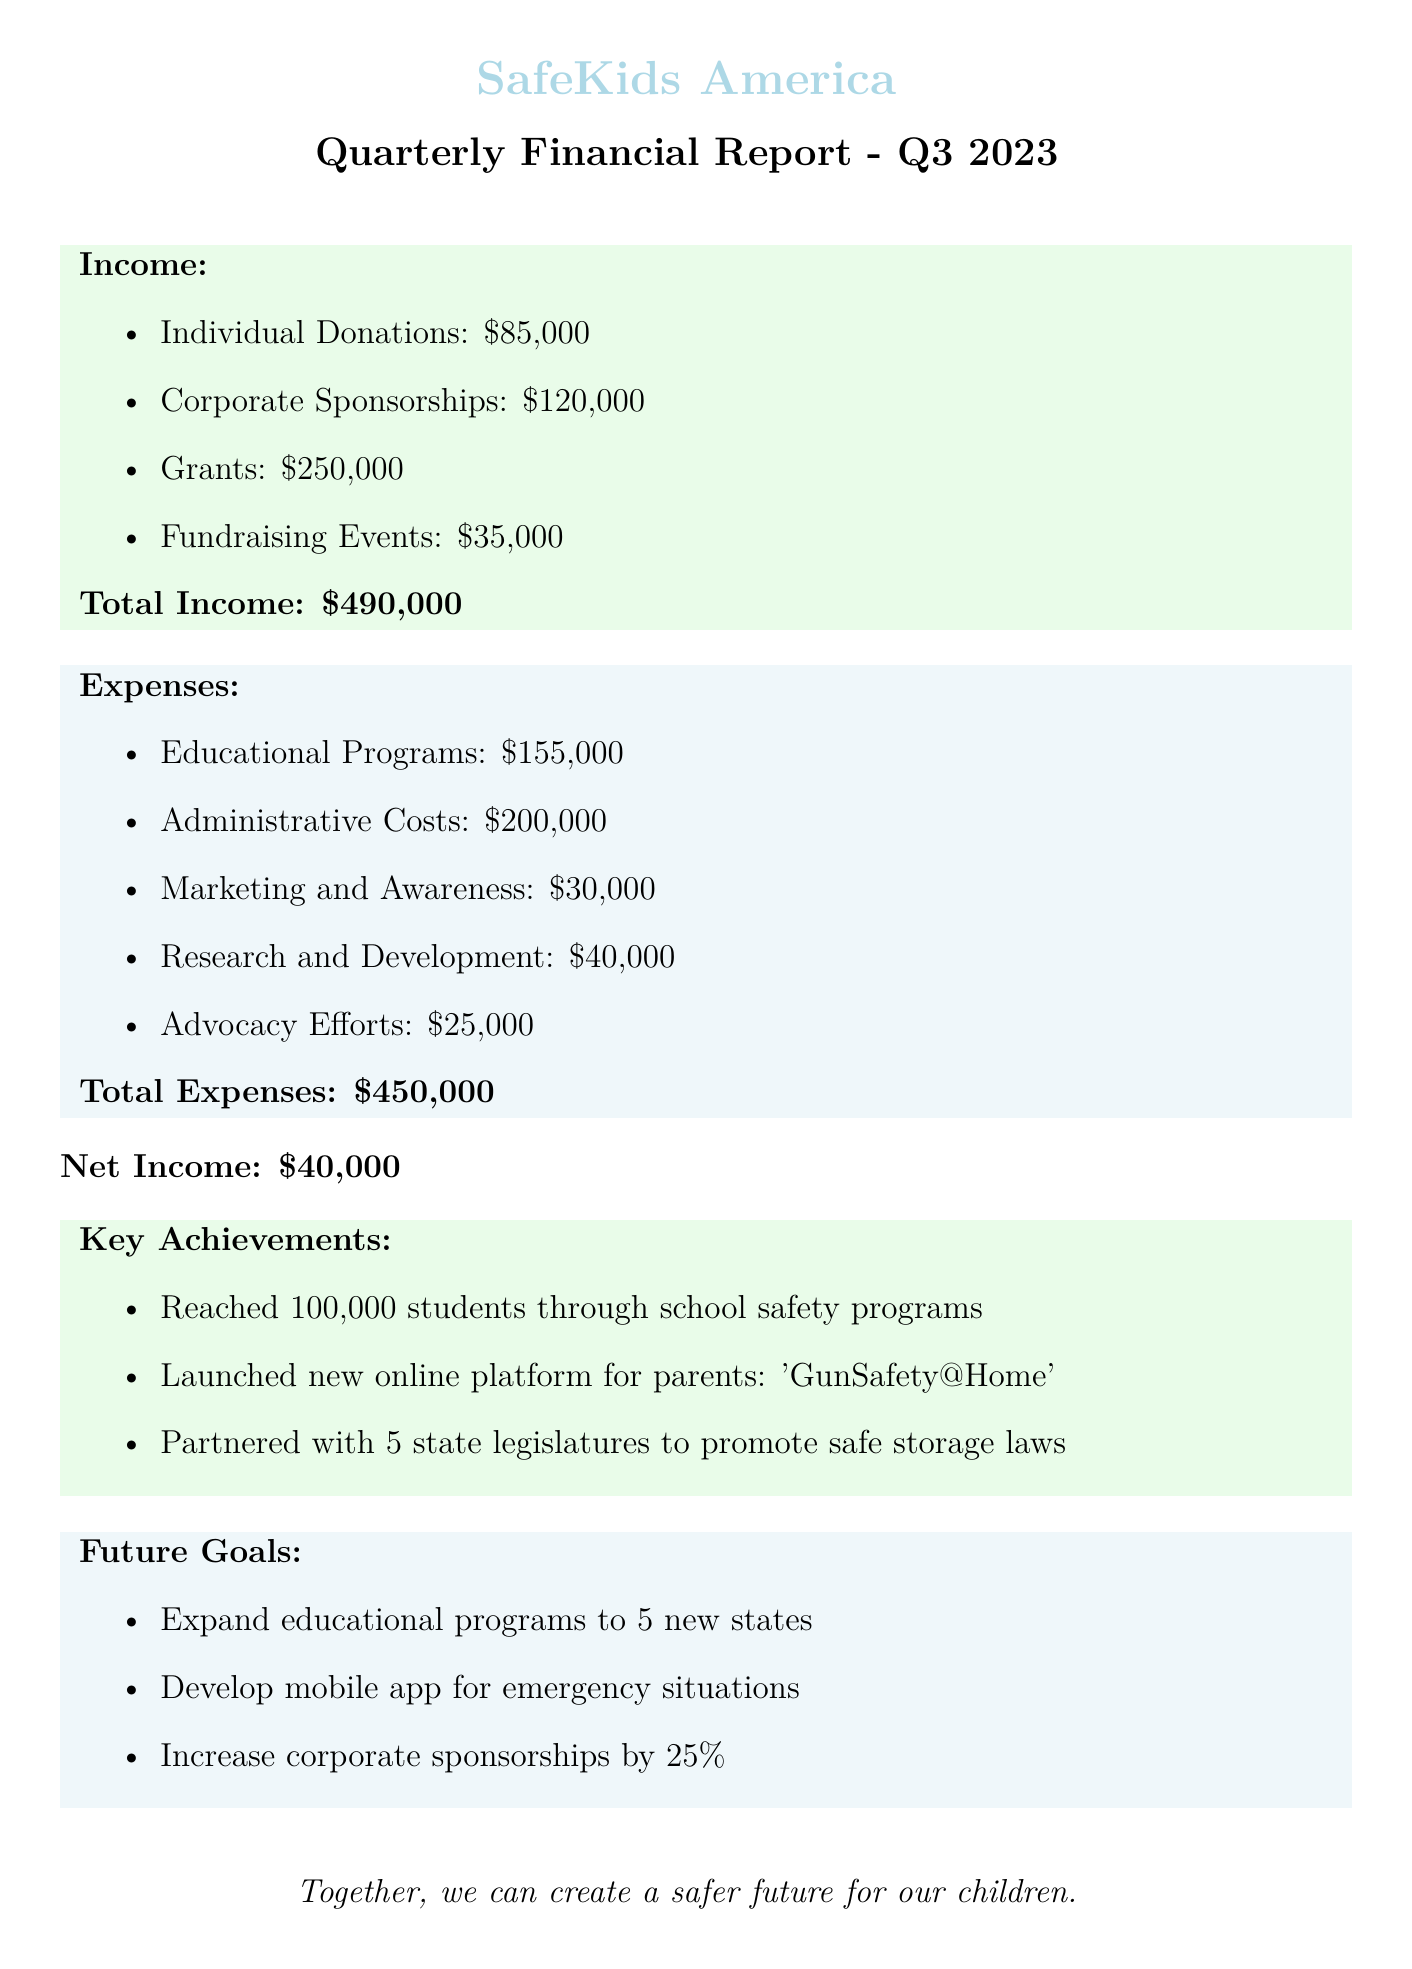what is the total income? The total income is calculated by adding all the income sources together, which amounts to $85,000 + $120,000 + $250,000 + $35,000 = $490,000.
Answer: $490,000 what is the expense for educational programs? The expense for educational programs includes the costs for school outreach, community workshops, and online resources, totaling $75,000 + $50,000 + $30,000 = $155,000.
Answer: $155,000 how much was spent on advocacy efforts? The document states that the expenses for advocacy efforts totaled $25,000.
Answer: $25,000 how many students were reached through school safety programs? According to the key achievements, 100,000 students were reached through school safety programs.
Answer: 100,000 what is the net income for Q3 2023? The net income is derived from subtracting total expenses from total income, yielding $490,000 - $450,000 = $40,000.
Answer: $40,000 what was the greatest source of income? Grants represent the greatest source of income at $250,000.
Answer: $250,000 how many new states does the organization plan to expand educational programs into? The future goals mention expanding educational programs to 5 new states.
Answer: 5 new states what is the total expense for administrative costs? The total expense for administrative costs is calculated as follows: $180,000 + $15,000 + $5,000 = $200,000.
Answer: $200,000 what is one future goal of the organization? One future goal mentioned in the document is to develop a mobile app for emergency situations.
Answer: Develop mobile app for emergency situations 